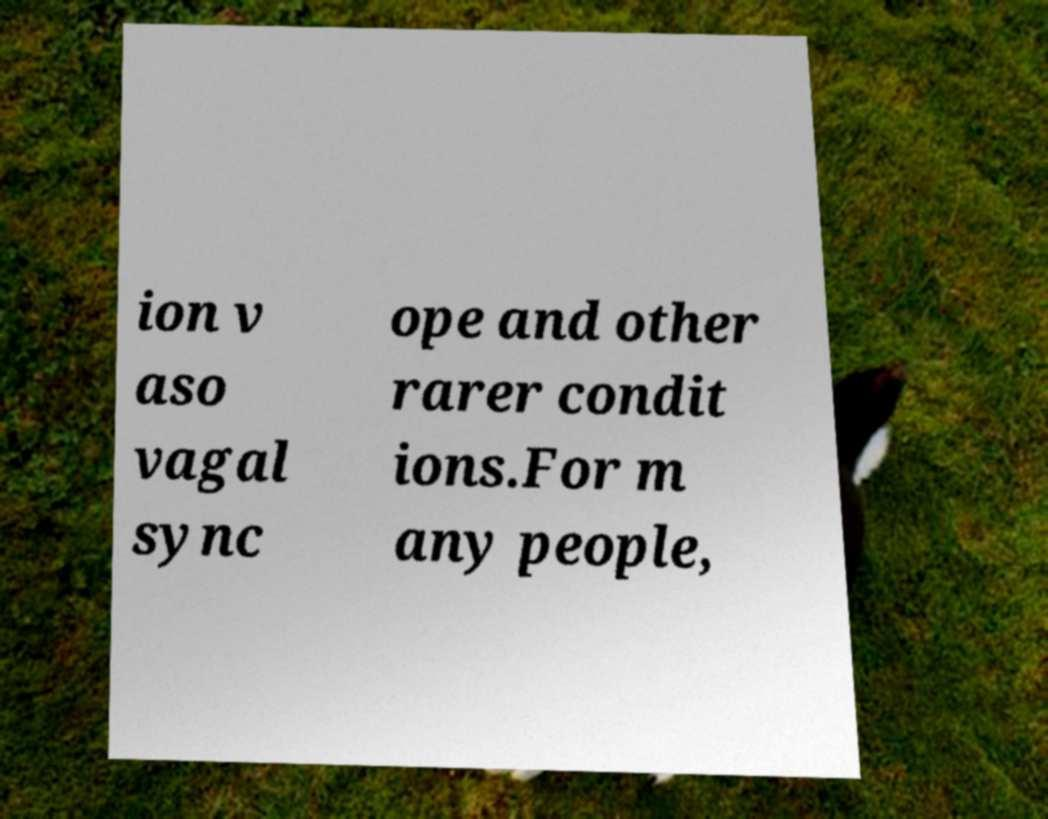Can you accurately transcribe the text from the provided image for me? ion v aso vagal sync ope and other rarer condit ions.For m any people, 